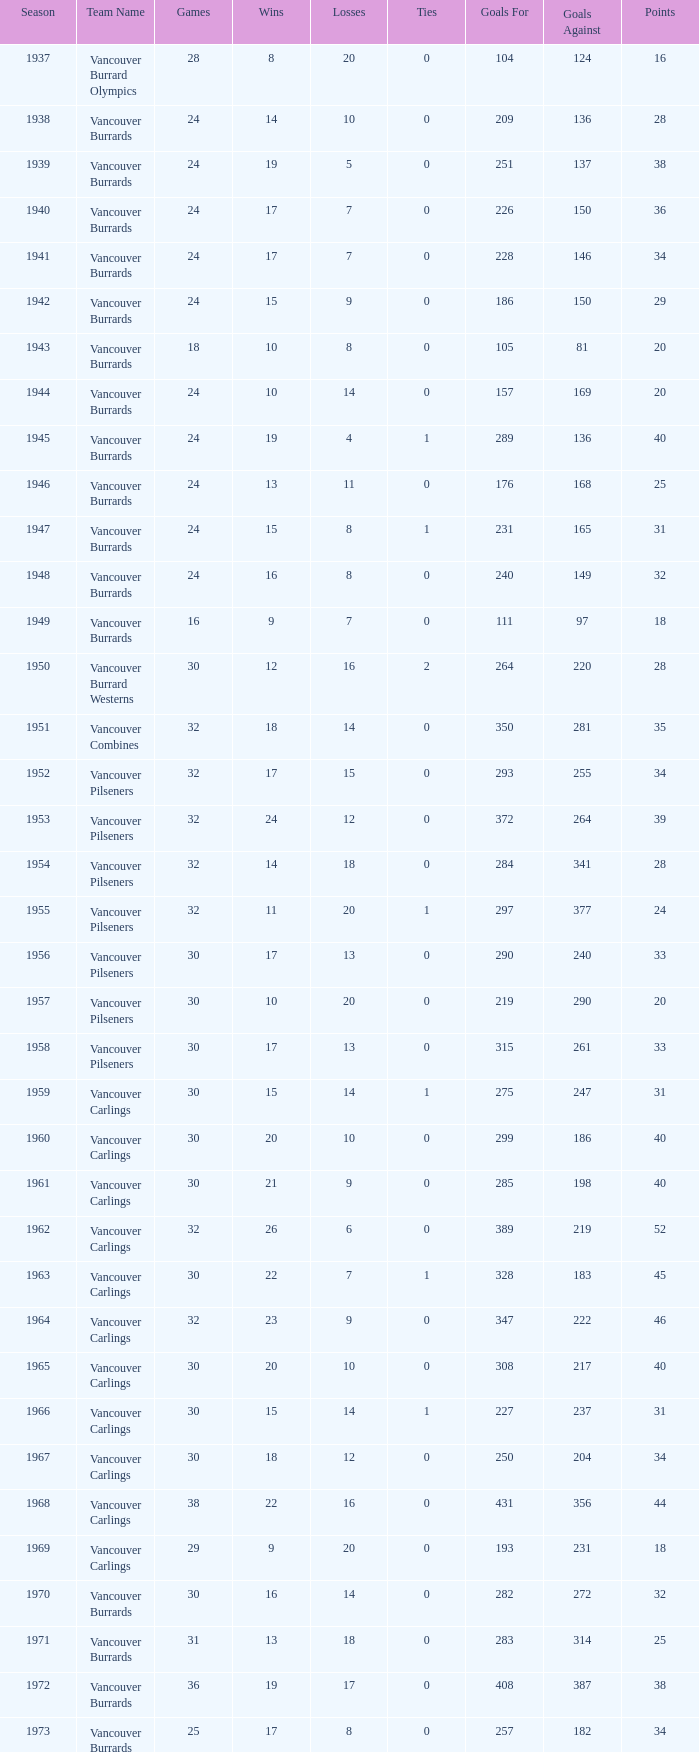What's the sum of points for the 1963 season when there are more than 30 games? None. Can you parse all the data within this table? {'header': ['Season', 'Team Name', 'Games', 'Wins', 'Losses', 'Ties', 'Goals For', 'Goals Against', 'Points'], 'rows': [['1937', 'Vancouver Burrard Olympics', '28', '8', '20', '0', '104', '124', '16'], ['1938', 'Vancouver Burrards', '24', '14', '10', '0', '209', '136', '28'], ['1939', 'Vancouver Burrards', '24', '19', '5', '0', '251', '137', '38'], ['1940', 'Vancouver Burrards', '24', '17', '7', '0', '226', '150', '36'], ['1941', 'Vancouver Burrards', '24', '17', '7', '0', '228', '146', '34'], ['1942', 'Vancouver Burrards', '24', '15', '9', '0', '186', '150', '29'], ['1943', 'Vancouver Burrards', '18', '10', '8', '0', '105', '81', '20'], ['1944', 'Vancouver Burrards', '24', '10', '14', '0', '157', '169', '20'], ['1945', 'Vancouver Burrards', '24', '19', '4', '1', '289', '136', '40'], ['1946', 'Vancouver Burrards', '24', '13', '11', '0', '176', '168', '25'], ['1947', 'Vancouver Burrards', '24', '15', '8', '1', '231', '165', '31'], ['1948', 'Vancouver Burrards', '24', '16', '8', '0', '240', '149', '32'], ['1949', 'Vancouver Burrards', '16', '9', '7', '0', '111', '97', '18'], ['1950', 'Vancouver Burrard Westerns', '30', '12', '16', '2', '264', '220', '28'], ['1951', 'Vancouver Combines', '32', '18', '14', '0', '350', '281', '35'], ['1952', 'Vancouver Pilseners', '32', '17', '15', '0', '293', '255', '34'], ['1953', 'Vancouver Pilseners', '32', '24', '12', '0', '372', '264', '39'], ['1954', 'Vancouver Pilseners', '32', '14', '18', '0', '284', '341', '28'], ['1955', 'Vancouver Pilseners', '32', '11', '20', '1', '297', '377', '24'], ['1956', 'Vancouver Pilseners', '30', '17', '13', '0', '290', '240', '33'], ['1957', 'Vancouver Pilseners', '30', '10', '20', '0', '219', '290', '20'], ['1958', 'Vancouver Pilseners', '30', '17', '13', '0', '315', '261', '33'], ['1959', 'Vancouver Carlings', '30', '15', '14', '1', '275', '247', '31'], ['1960', 'Vancouver Carlings', '30', '20', '10', '0', '299', '186', '40'], ['1961', 'Vancouver Carlings', '30', '21', '9', '0', '285', '198', '40'], ['1962', 'Vancouver Carlings', '32', '26', '6', '0', '389', '219', '52'], ['1963', 'Vancouver Carlings', '30', '22', '7', '1', '328', '183', '45'], ['1964', 'Vancouver Carlings', '32', '23', '9', '0', '347', '222', '46'], ['1965', 'Vancouver Carlings', '30', '20', '10', '0', '308', '217', '40'], ['1966', 'Vancouver Carlings', '30', '15', '14', '1', '227', '237', '31'], ['1967', 'Vancouver Carlings', '30', '18', '12', '0', '250', '204', '34'], ['1968', 'Vancouver Carlings', '38', '22', '16', '0', '431', '356', '44'], ['1969', 'Vancouver Carlings', '29', '9', '20', '0', '193', '231', '18'], ['1970', 'Vancouver Burrards', '30', '16', '14', '0', '282', '272', '32'], ['1971', 'Vancouver Burrards', '31', '13', '18', '0', '283', '314', '25'], ['1972', 'Vancouver Burrards', '36', '19', '17', '0', '408', '387', '38'], ['1973', 'Vancouver Burrards', '25', '17', '8', '0', '257', '182', '34'], ['1974', 'Vancouver Burrards', '24', '11', '13', '0', '219', '232', '22'], ['1975', 'Vancouver Burrards', '24', '14', '10', '0', '209', '187', '28'], ['1976', 'Vancouver Burrards', '24', '10', '14', '0', '182', '205', '20'], ['1977', 'Vancouver Burrards', '24', '17', '7', '0', '240', '184', '33'], ['1978', 'Vancouver Burrards', '24', '11', '13', '0', '194', '223', '22'], ['1979', 'Vancouver Burrards', '30', '11', '19', '0', '228', '283', '22'], ['1980', 'Vancouver Burrards', '24', '11', '13', '0', '177', '195', '22'], ['1981', 'Vancouver Burrards', '24', '12', '12', '0', '192', '183', '24'], ['1982', 'Vancouver Burrards', '24', '12', '12', '0', '202', '201', '24'], ['1983', 'Vancouver Burrards', '24', '14', '10', '0', '217', '194', '28'], ['1984', 'Vancouver Burrards', '24', '9', '15', '0', '181', '205', '18'], ['1985', 'Vancouver Burrards', '24', '11', '13', '0', '179', '191', '22'], ['1986', 'Vancouver Burrards', '24', '14', '11', '0', '203', '177', '26'], ['1987', 'Vancouver Burrards', '24', '10', '14', '0', '203', '220', '20'], ['1988', 'Vancouver Burrards', '24', '11', '13', '0', '195', '180', '22'], ['1989', 'Vancouver Burrards', '24', '9', '15', '0', '201', '227', '18'], ['1990', 'Vancouver Burrards', '24', '16', '8', '0', '264', '192', '32'], ['1991', 'Vancouver Burrards', '24', '8', '16', '0', '201', '225', '16'], ['1992', 'Vancouver Burrards', '24', '9', '15', '0', '157', '186', '18'], ['1993', 'Vancouver Burrards', '24', '3', '20', '1', '132', '218', '8'], ['1994', 'Surrey Burrards', '20', '8', '12', '0', '162', '196', '16'], ['1995', 'Surrey Burrards', '25', '6', '19', '0', '216', '319', '11'], ['1996', 'Maple Ridge Burrards', '20', '15', '8', '0', '211', '150', '23'], ['1997', 'Maple Ridge Burrards', '20', '11', '8', '0', '180', '158', '23'], ['1998', 'Maple Ridge Burrards', '25', '24', '8', '0', '305', '179', '32'], ['1999', 'Maple Ridge Burrards', '25', '5', '15', '5', '212', '225', '20'], ['2000', 'Maple Ridge Burrards', '25', '4', '16', '5', '175', '224', '18'], ['2001', 'Maple Ridge Burrards', '20', '3', '16', '1', '120', '170', '8'], ['2002', 'Maple Ridge Burrards', '20', '4', '15', '1', '132', '186', '8'], ['2003', 'Maple Ridge Burrards', '20', '5', '15', '1', '149', '179', '10'], ['2004', 'Maple Ridge Burrards', '20', '8', '12', '0', '159', '156', '16'], ['2005', 'Maple Ridge Burrards', '18', '10', '8', '0', '156', '136', '19'], ['2006', 'Maple Ridge Burrards', '18', '7', '11', '0', '143', '153', '14'], ['2007', 'Maple Ridge Burrards', '18', '7', '11', '0', '156', '182', '14'], ['2008', 'Maple Ridge Burrards', '18', '5', '13', '0', '137', '150', '10'], ['2009', 'Maple Ridge Burrards', '18', '7', '11', '0', '144', '162', '14'], ['2010', 'Maple Ridge Burrards', '18', '9', '9', '0', '149', '136', '18'], ['Total', '74 seasons', '1,879', '913', '913', '1,916', '14,845', '13,929', '1,916']]} 